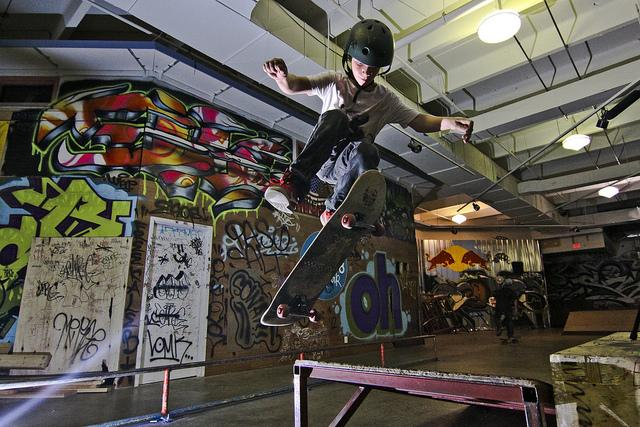How did the skateboarder get so high in the air?

Choices:
A) vaulted
B) ramp
C) trampoline
D) spring board ramp 